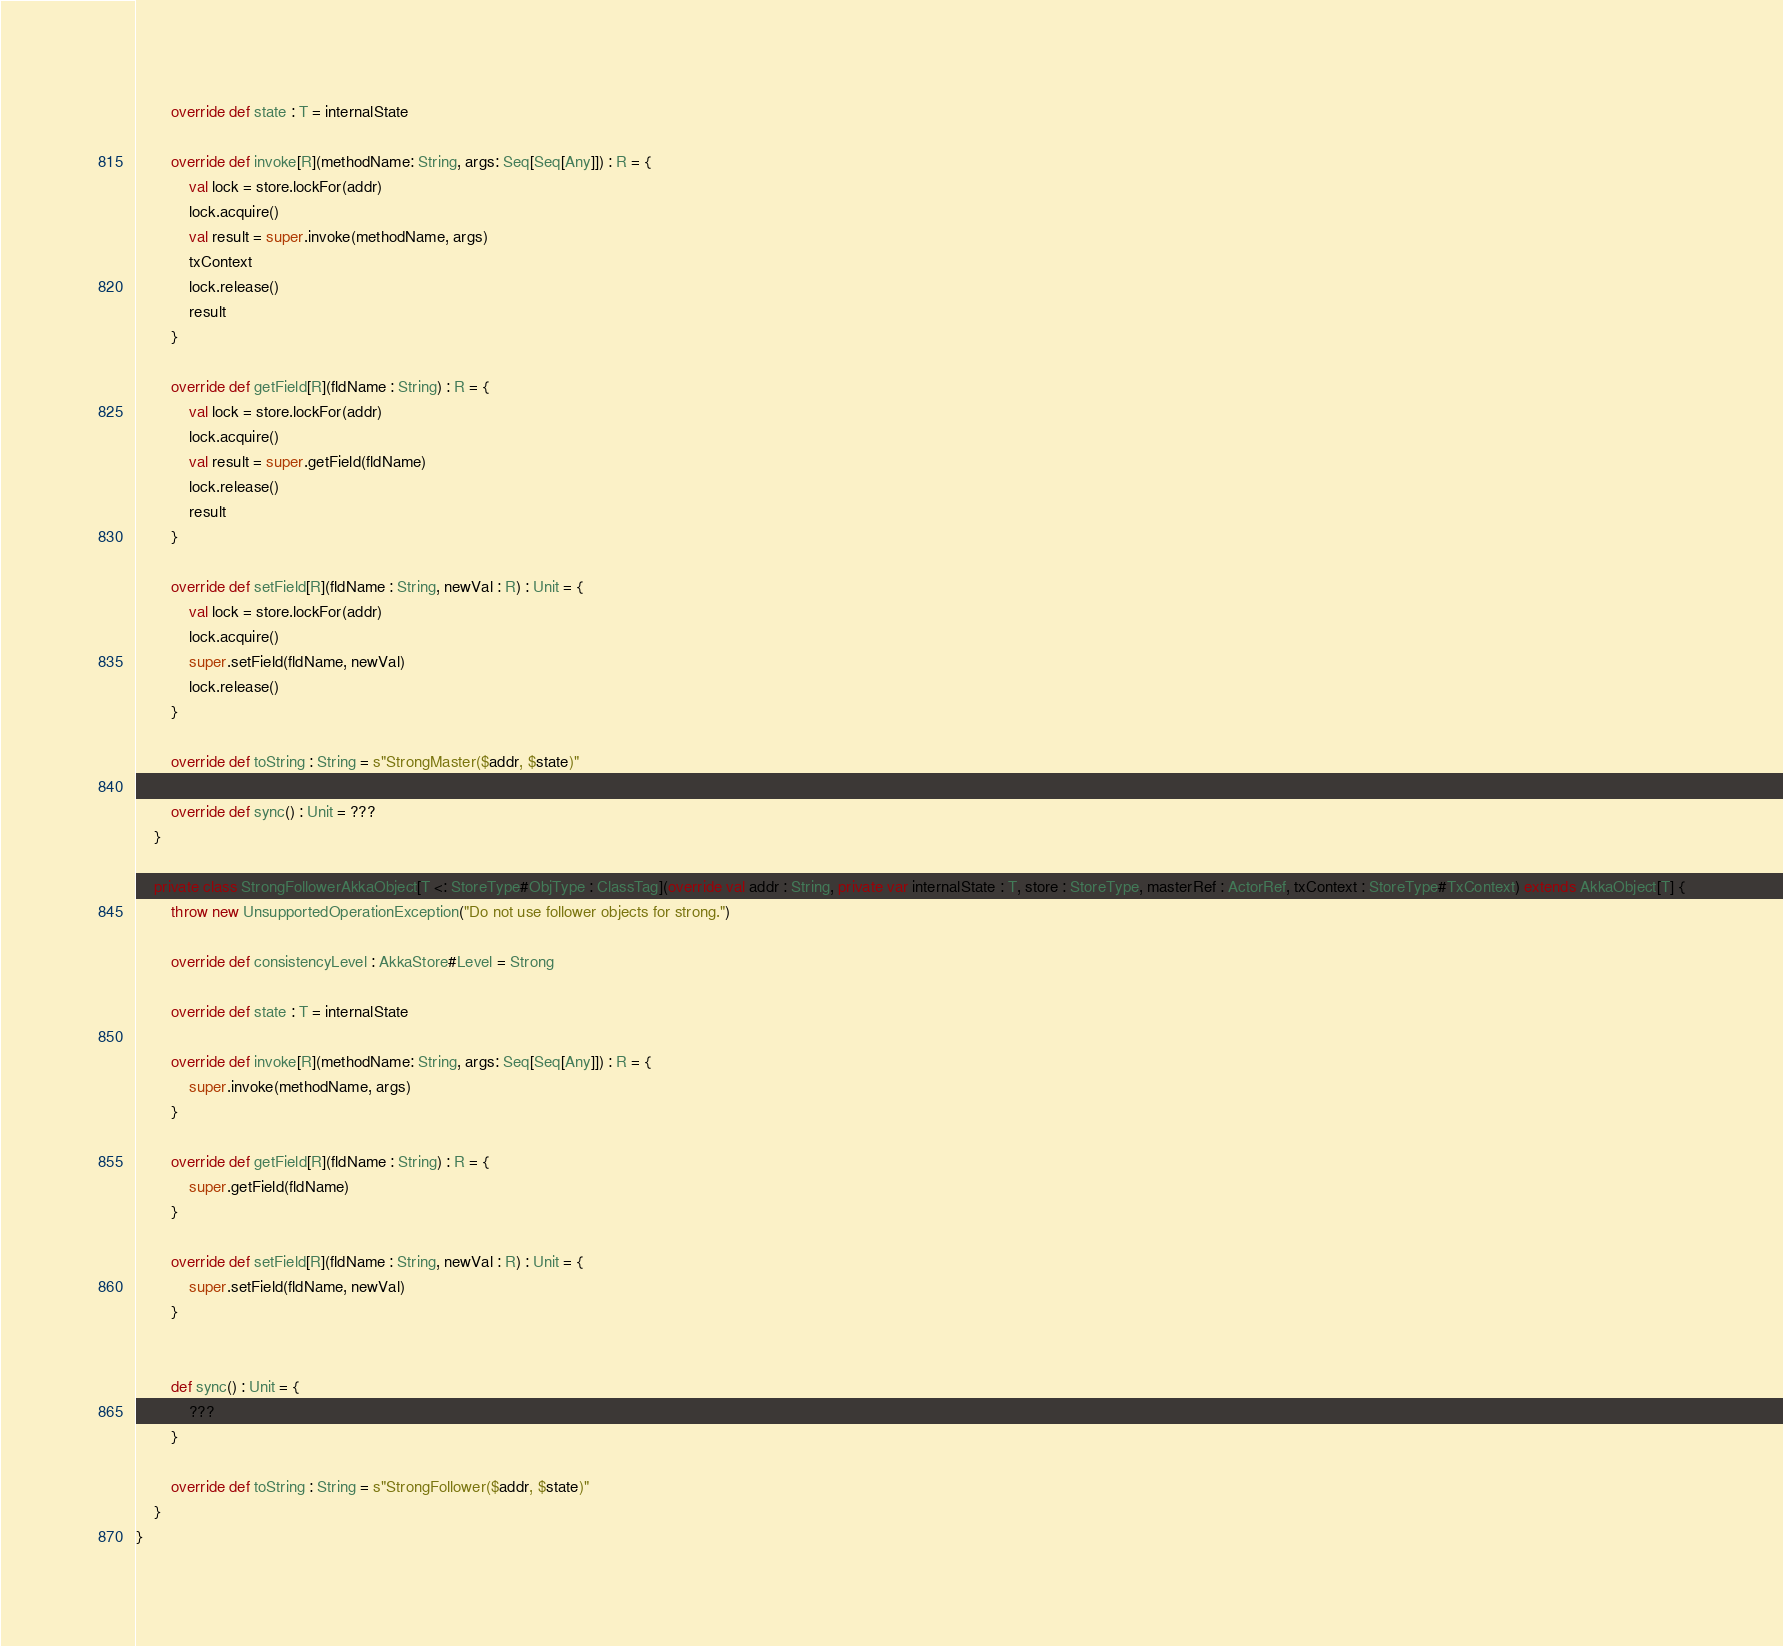<code> <loc_0><loc_0><loc_500><loc_500><_Scala_>
		override def state : T = internalState

		override def invoke[R](methodName: String, args: Seq[Seq[Any]]) : R = {
			val lock = store.lockFor(addr)
			lock.acquire()
			val result = super.invoke(methodName, args)
			txContext
			lock.release()
			result
		}

		override def getField[R](fldName : String) : R = {
			val lock = store.lockFor(addr)
			lock.acquire()
			val result = super.getField(fldName)
			lock.release()
			result
		}

		override def setField[R](fldName : String, newVal : R) : Unit = {
			val lock = store.lockFor(addr)
			lock.acquire()
			super.setField(fldName, newVal)
			lock.release()
		}

		override def toString : String = s"StrongMaster($addr, $state)"

		override def sync() : Unit = ???
	}

	private class StrongFollowerAkkaObject[T <: StoreType#ObjType : ClassTag](override val addr : String, private var internalState : T, store : StoreType, masterRef : ActorRef, txContext : StoreType#TxContext) extends AkkaObject[T] {
		throw new UnsupportedOperationException("Do not use follower objects for strong.")

		override def consistencyLevel : AkkaStore#Level = Strong

		override def state : T = internalState

		override def invoke[R](methodName: String, args: Seq[Seq[Any]]) : R = {
			super.invoke(methodName, args)
		}

		override def getField[R](fldName : String) : R = {
			super.getField(fldName)
		}

		override def setField[R](fldName : String, newVal : R) : Unit = {
			super.setField(fldName, newVal)
		}


		def sync() : Unit = {
			???
		}

		override def toString : String = s"StrongFollower($addr, $state)"
	}
}




</code> 